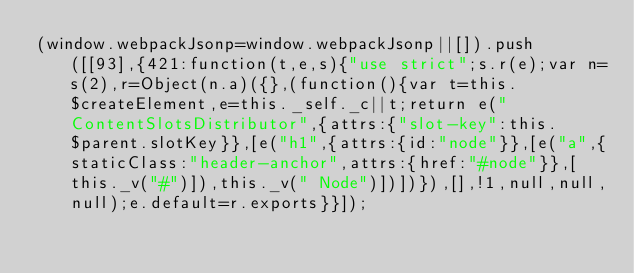Convert code to text. <code><loc_0><loc_0><loc_500><loc_500><_JavaScript_>(window.webpackJsonp=window.webpackJsonp||[]).push([[93],{421:function(t,e,s){"use strict";s.r(e);var n=s(2),r=Object(n.a)({},(function(){var t=this.$createElement,e=this._self._c||t;return e("ContentSlotsDistributor",{attrs:{"slot-key":this.$parent.slotKey}},[e("h1",{attrs:{id:"node"}},[e("a",{staticClass:"header-anchor",attrs:{href:"#node"}},[this._v("#")]),this._v(" Node")])])}),[],!1,null,null,null);e.default=r.exports}}]);</code> 